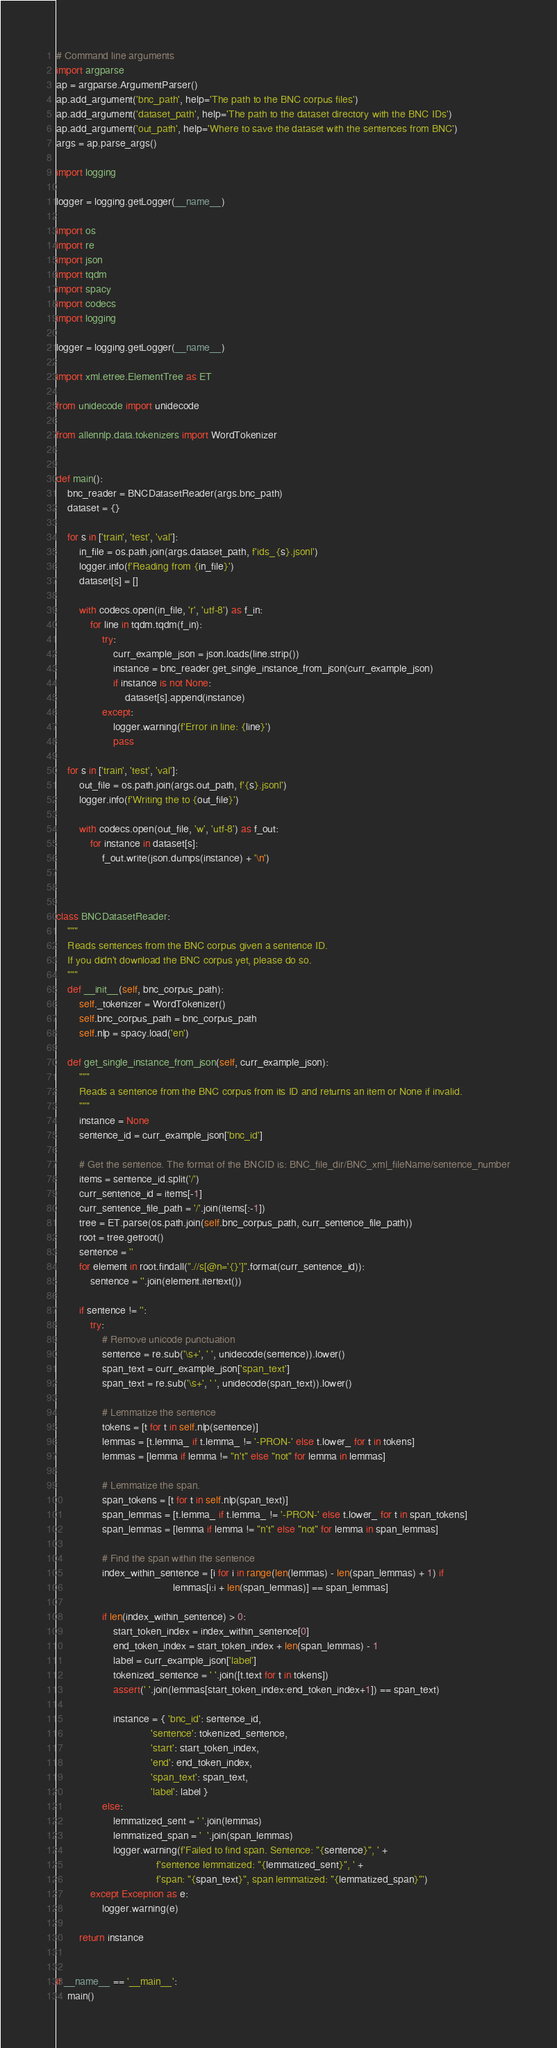Convert code to text. <code><loc_0><loc_0><loc_500><loc_500><_Python_># Command line arguments
import argparse
ap = argparse.ArgumentParser()
ap.add_argument('bnc_path', help='The path to the BNC corpus files')
ap.add_argument('dataset_path', help='The path to the dataset directory with the BNC IDs')
ap.add_argument('out_path', help='Where to save the dataset with the sentences from BNC')
args = ap.parse_args()

import logging

logger = logging.getLogger(__name__)

import os
import re
import json
import tqdm
import spacy
import codecs
import logging

logger = logging.getLogger(__name__)

import xml.etree.ElementTree as ET

from unidecode import unidecode

from allennlp.data.tokenizers import WordTokenizer


def main():
    bnc_reader = BNCDatasetReader(args.bnc_path)
    dataset = {}

    for s in ['train', 'test', 'val']:
        in_file = os.path.join(args.dataset_path, f'ids_{s}.jsonl')
        logger.info(f'Reading from {in_file}')
        dataset[s] = []

        with codecs.open(in_file, 'r', 'utf-8') as f_in:
            for line in tqdm.tqdm(f_in):
                try:
                    curr_example_json = json.loads(line.strip())
                    instance = bnc_reader.get_single_instance_from_json(curr_example_json)
                    if instance is not None:
                        dataset[s].append(instance)
                except:
                    logger.warning(f'Error in line: {line}')
                    pass

    for s in ['train', 'test', 'val']:
        out_file = os.path.join(args.out_path, f'{s}.jsonl')
        logger.info(f'Writing the to {out_file}')

        with codecs.open(out_file, 'w', 'utf-8') as f_out:
            for instance in dataset[s]:
                f_out.write(json.dumps(instance) + '\n')



class BNCDatasetReader:
    """
    Reads sentences from the BNC corpus given a sentence ID.
    If you didn't download the BNC corpus yet, please do so.
    """
    def __init__(self, bnc_corpus_path):
        self._tokenizer = WordTokenizer()
        self.bnc_corpus_path = bnc_corpus_path
        self.nlp = spacy.load('en')

    def get_single_instance_from_json(self, curr_example_json):
        """
        Reads a sentence from the BNC corpus from its ID and returns an item or None if invalid.
        """
        instance = None
        sentence_id = curr_example_json['bnc_id']

        # Get the sentence. The format of the BNCID is: BNC_file_dir/BNC_xml_fileName/sentence_number
        items = sentence_id.split('/')
        curr_sentence_id = items[-1]
        curr_sentence_file_path = '/'.join(items[:-1])
        tree = ET.parse(os.path.join(self.bnc_corpus_path, curr_sentence_file_path))
        root = tree.getroot()
        sentence = ''
        for element in root.findall(".//s[@n='{}']".format(curr_sentence_id)):
            sentence = ''.join(element.itertext())

        if sentence != '':
            try:
                # Remove unicode punctuation
                sentence = re.sub('\s+', ' ', unidecode(sentence)).lower()
                span_text = curr_example_json['span_text']
                span_text = re.sub('\s+', ' ', unidecode(span_text)).lower()

                # Lemmatize the sentence
                tokens = [t for t in self.nlp(sentence)]
                lemmas = [t.lemma_ if t.lemma_ != '-PRON-' else t.lower_ for t in tokens]
                lemmas = [lemma if lemma != "n't" else "not" for lemma in lemmas]

                # Lemmatize the span.
                span_tokens = [t for t in self.nlp(span_text)]
                span_lemmas = [t.lemma_ if t.lemma_ != '-PRON-' else t.lower_ for t in span_tokens]
                span_lemmas = [lemma if lemma != "n't" else "not" for lemma in span_lemmas]

                # Find the span within the sentence
                index_within_sentence = [i for i in range(len(lemmas) - len(span_lemmas) + 1) if
                                         lemmas[i:i + len(span_lemmas)] == span_lemmas]

                if len(index_within_sentence) > 0:
                    start_token_index = index_within_sentence[0]
                    end_token_index = start_token_index + len(span_lemmas) - 1
                    label = curr_example_json['label']
                    tokenized_sentence = ' '.join([t.text for t in tokens])
                    assert(' '.join(lemmas[start_token_index:end_token_index+1]) == span_text)

                    instance = { 'bnc_id': sentence_id,
                                 'sentence': tokenized_sentence,
                                 'start': start_token_index,
                                 'end': end_token_index,
                                 'span_text': span_text,
                                 'label': label }
                else:
                    lemmatized_sent = ' '.join(lemmas)
                    lemmatized_span = '  '.join(span_lemmas)
                    logger.warning(f'Failed to find span. Sentence: "{sentence}", ' +
                                   f'sentence lemmatized: "{lemmatized_sent}", ' +
                                   f'span: "{span_text}", span lemmatized: "{lemmatized_span}"')
            except Exception as e:
                logger.warning(e)

        return instance


if __name__ == '__main__':
    main()
</code> 